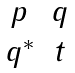Convert formula to latex. <formula><loc_0><loc_0><loc_500><loc_500>\begin{matrix} p & q \\ q ^ { * } & t \end{matrix}</formula> 